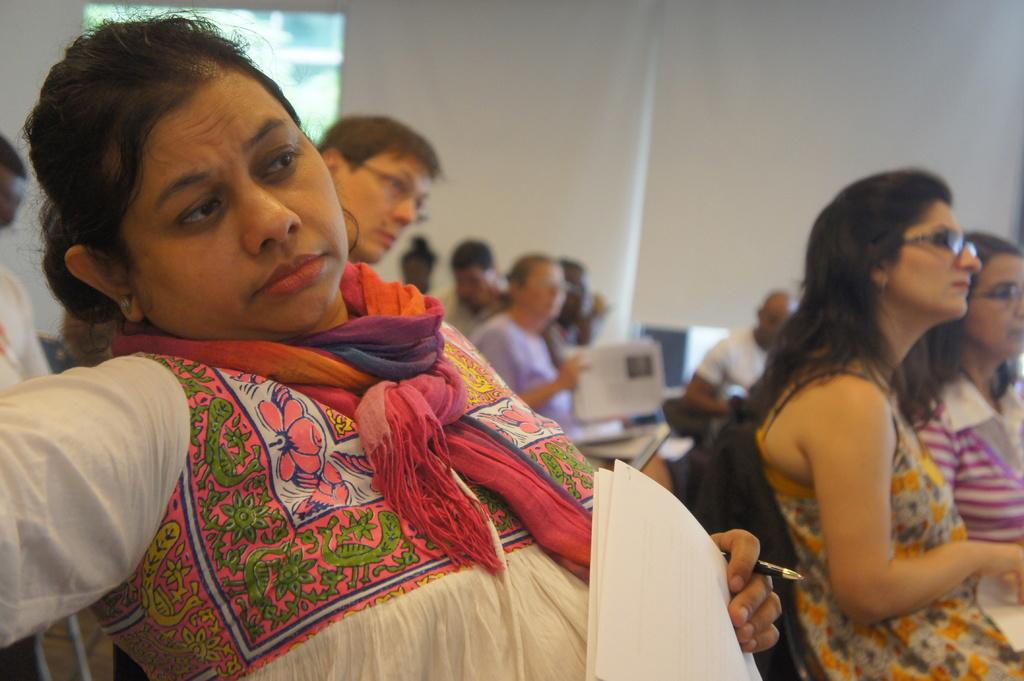What are the people in the image doing? The people in the image are sitting on chairs. What objects are the people holding in the image? The people are holding papers and pens. What can be seen in the background of the image? There is a wall and a glass window in the background of the image. What type of harmony can be heard in the image? There is no music or sound present in the image, so it is not possible to determine if any harmony can be heard. 